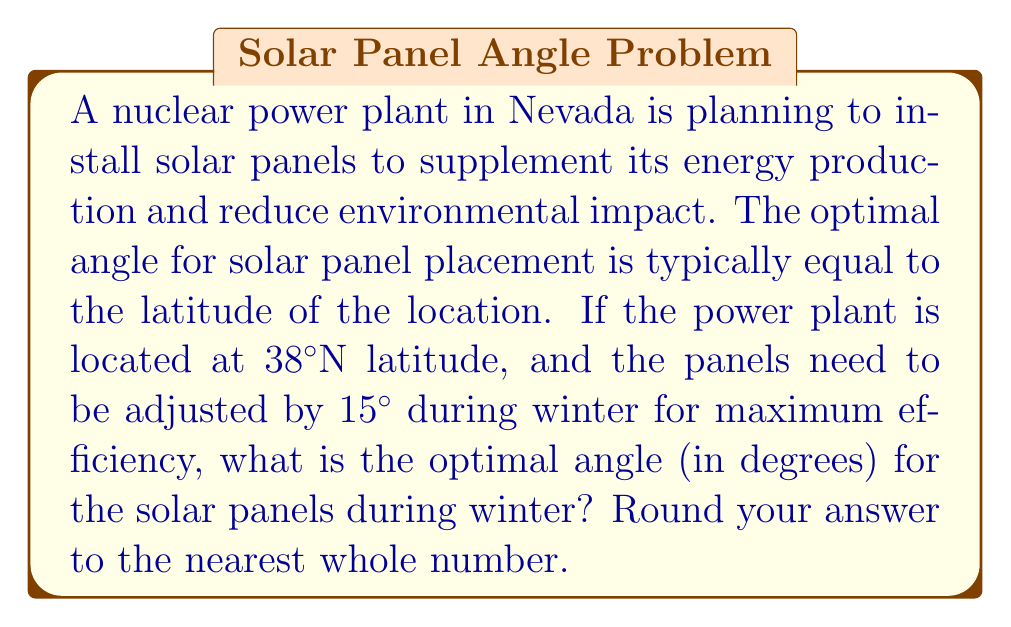Provide a solution to this math problem. Let's approach this step-by-step:

1. The optimal angle for solar panel placement is generally equal to the latitude of the location.
   Optimal angle = Latitude = 38°

2. During winter, the panels need to be adjusted by an additional 15° for maximum efficiency.
   Winter adjustment = 15°

3. To find the optimal winter angle, we add the latitude and the winter adjustment:
   $$\text{Optimal winter angle} = \text{Latitude} + \text{Winter adjustment}$$
   $$\text{Optimal winter angle} = 38° + 15° = 53°$$

4. The question asks to round to the nearest whole number, but our result is already a whole number, so no further rounding is necessary.
Answer: 53° 